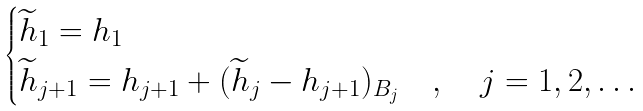<formula> <loc_0><loc_0><loc_500><loc_500>\begin{cases} \widetilde { h } _ { 1 } = h _ { 1 } \\ \widetilde { h } _ { j + 1 } = h _ { j + 1 } + ( \widetilde { h } _ { j } - h _ { j + 1 } ) _ { B _ { j } } & , \quad j = 1 , 2 , \dots \end{cases}</formula> 